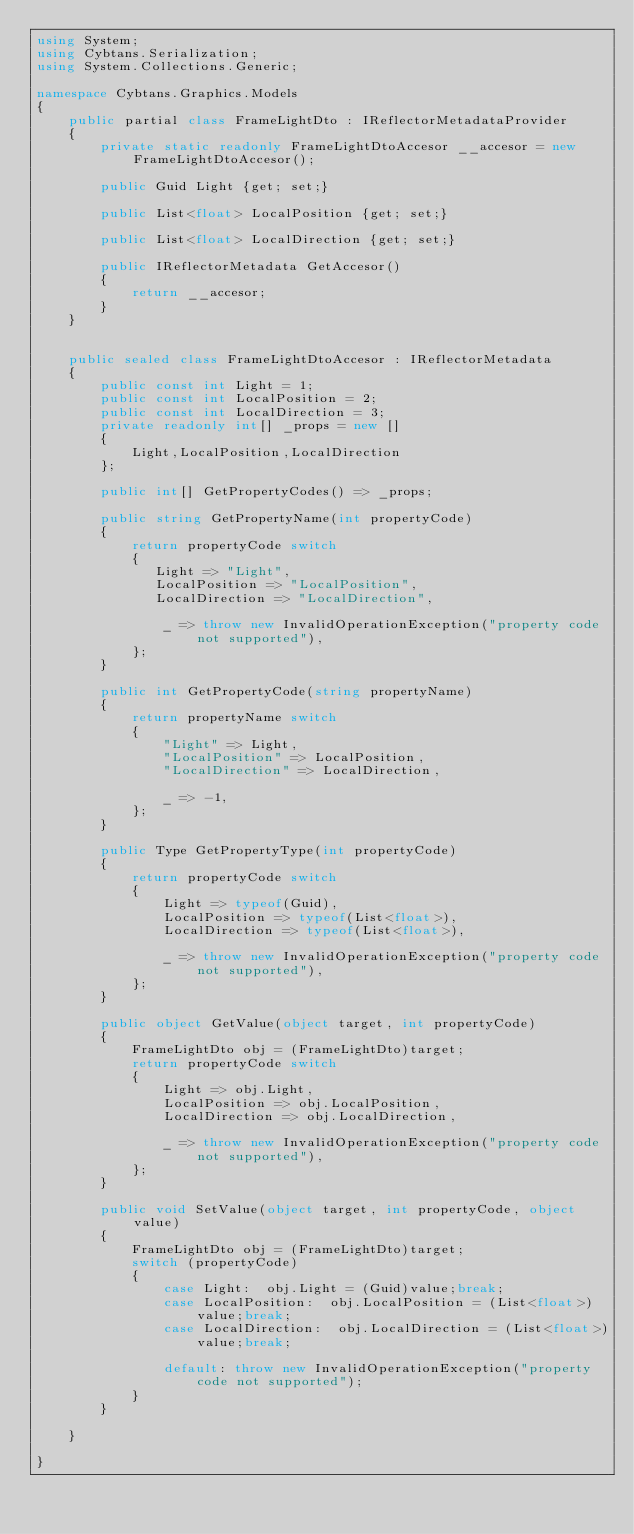<code> <loc_0><loc_0><loc_500><loc_500><_C#_>using System;
using Cybtans.Serialization;
using System.Collections.Generic;

namespace Cybtans.Graphics.Models
{
	public partial class FrameLightDto : IReflectorMetadataProvider
	{
		private static readonly FrameLightDtoAccesor __accesor = new FrameLightDtoAccesor();
		
		public Guid Light {get; set;}
		
		public List<float> LocalPosition {get; set;}
		
		public List<float> LocalDirection {get; set;}
		
		public IReflectorMetadata GetAccesor()
		{
			return __accesor;
		}
	}
	
	
	public sealed class FrameLightDtoAccesor : IReflectorMetadata
	{
		public const int Light = 1;
		public const int LocalPosition = 2;
		public const int LocalDirection = 3;
		private readonly int[] _props = new []
		{
			Light,LocalPosition,LocalDirection
		};
		
		public int[] GetPropertyCodes() => _props;
		
		public string GetPropertyName(int propertyCode)
		{
		    return propertyCode switch
		    {
		       Light => "Light",
		       LocalPosition => "LocalPosition",
		       LocalDirection => "LocalDirection",
		
		        _ => throw new InvalidOperationException("property code not supported"),
		    };
		}
		
		public int GetPropertyCode(string propertyName)
		{
		    return propertyName switch
		    {
		        "Light" => Light,
		        "LocalPosition" => LocalPosition,
		        "LocalDirection" => LocalDirection,
		
		        _ => -1,
		    };
		}
		
		public Type GetPropertyType(int propertyCode)
		{
		    return propertyCode switch
		    {
		        Light => typeof(Guid),
		        LocalPosition => typeof(List<float>),
		        LocalDirection => typeof(List<float>),
		
		        _ => throw new InvalidOperationException("property code not supported"),
		    };
		}
		       
		public object GetValue(object target, int propertyCode)
		{
		    FrameLightDto obj = (FrameLightDto)target;
		    return propertyCode switch
		    {
		        Light => obj.Light,
		        LocalPosition => obj.LocalPosition,
		        LocalDirection => obj.LocalDirection,
		
		        _ => throw new InvalidOperationException("property code not supported"),
		    };
		}
		
		public void SetValue(object target, int propertyCode, object value)
		{
		    FrameLightDto obj = (FrameLightDto)target;
		    switch (propertyCode)
		    {
		        case Light:  obj.Light = (Guid)value;break;
		        case LocalPosition:  obj.LocalPosition = (List<float>)value;break;
		        case LocalDirection:  obj.LocalDirection = (List<float>)value;break;
		
		        default: throw new InvalidOperationException("property code not supported");
		    }
		}
	
	}

}
</code> 